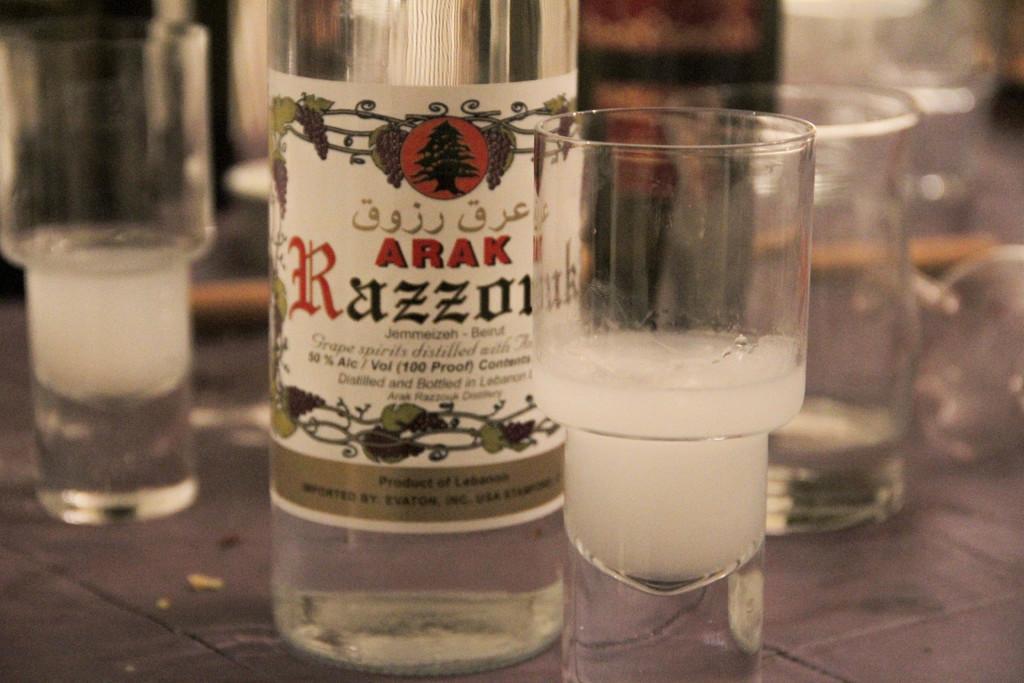In one or two sentences, can you explain what this image depicts? There is a glass bottle and few glasses beside it. 